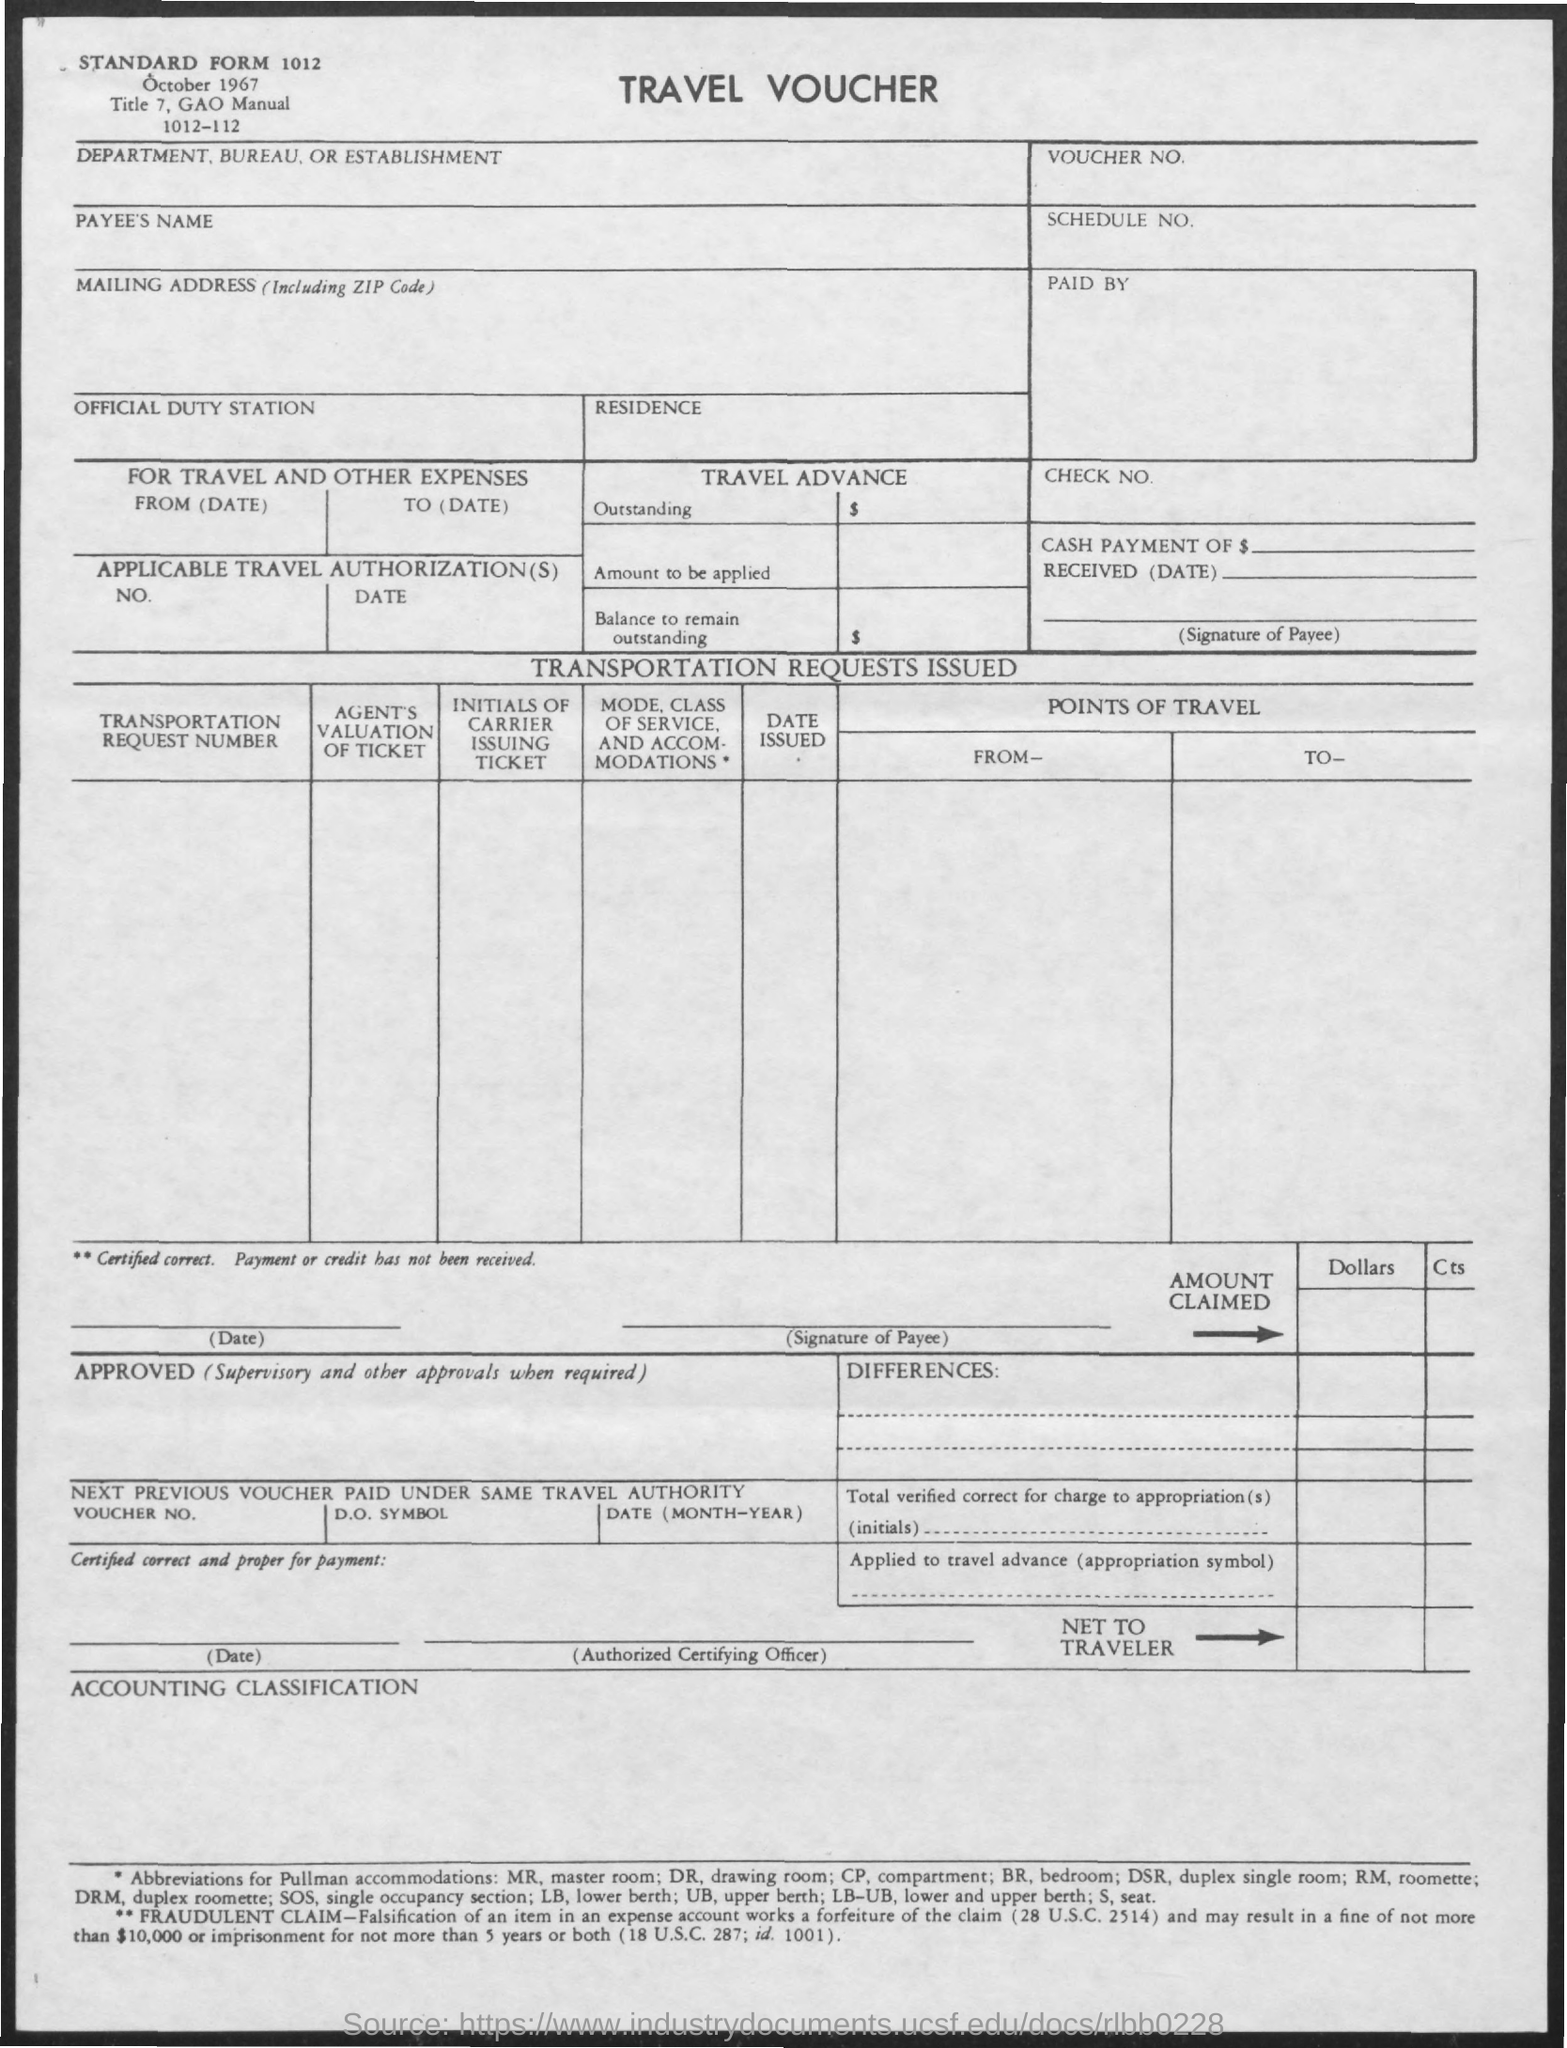Point out several critical features in this image. The title of the document is a travel voucher. The date mentioned in the document is October 1967. 